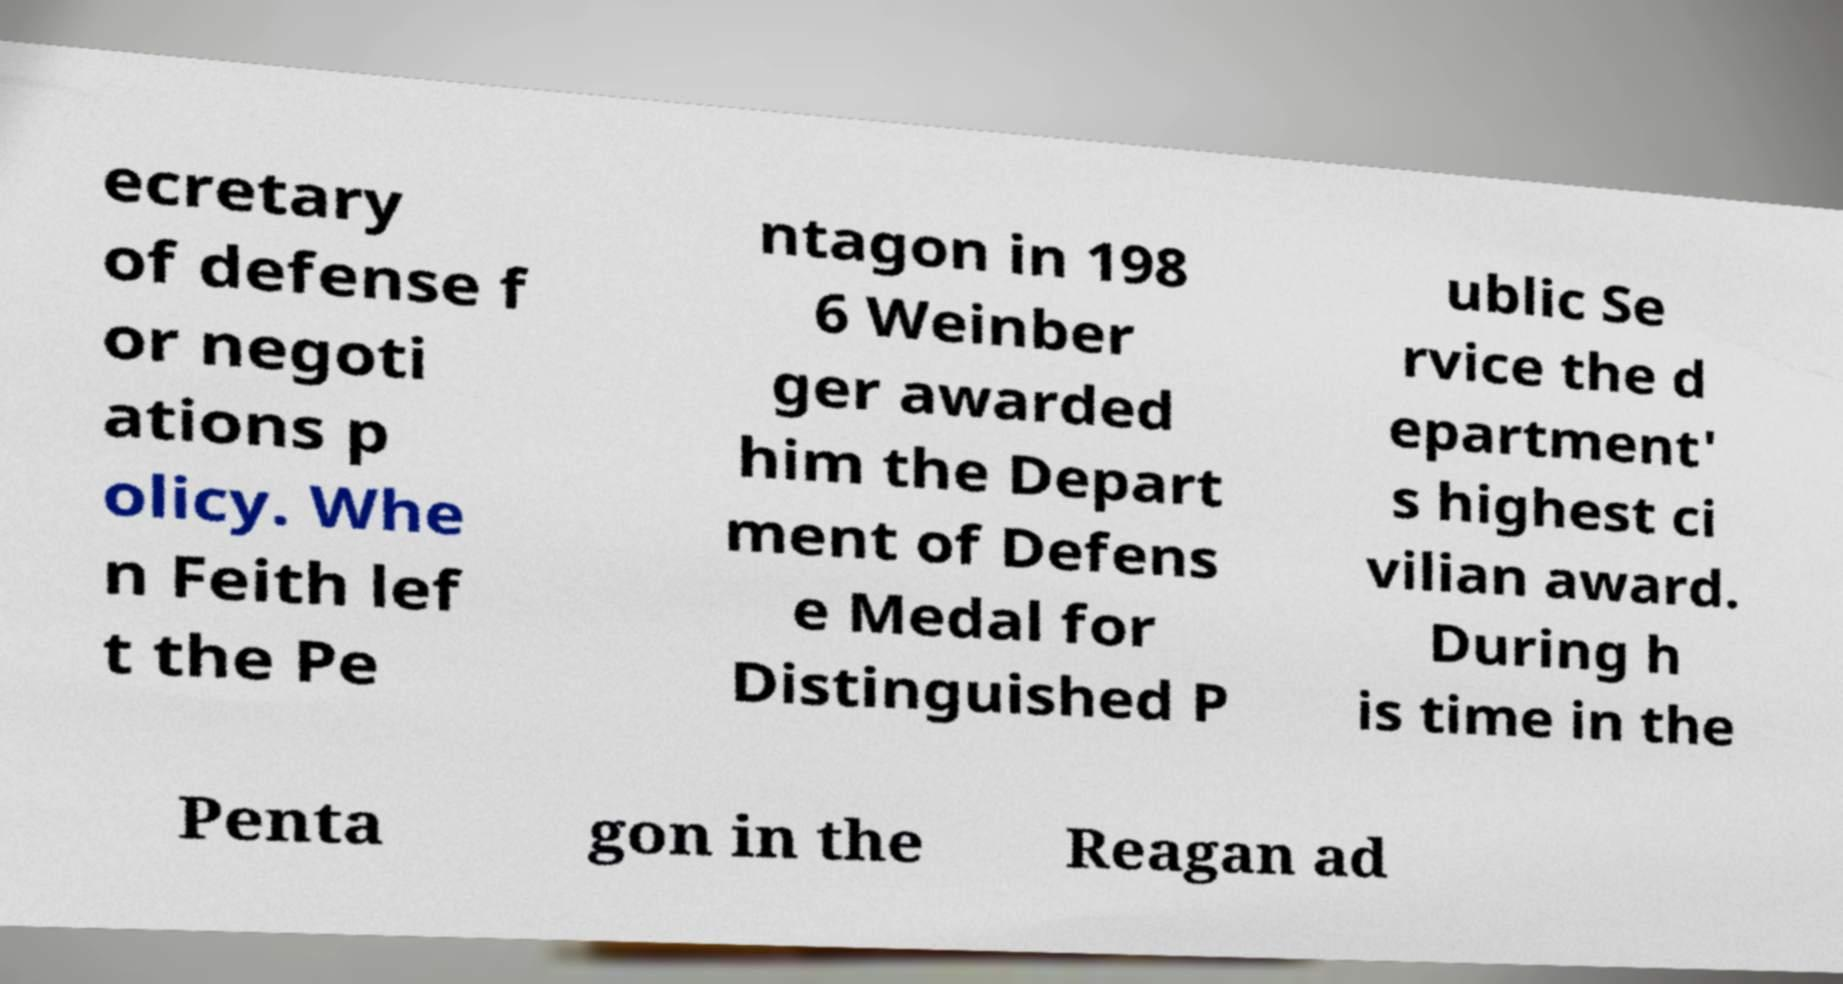For documentation purposes, I need the text within this image transcribed. Could you provide that? ecretary of defense f or negoti ations p olicy. Whe n Feith lef t the Pe ntagon in 198 6 Weinber ger awarded him the Depart ment of Defens e Medal for Distinguished P ublic Se rvice the d epartment' s highest ci vilian award. During h is time in the Penta gon in the Reagan ad 